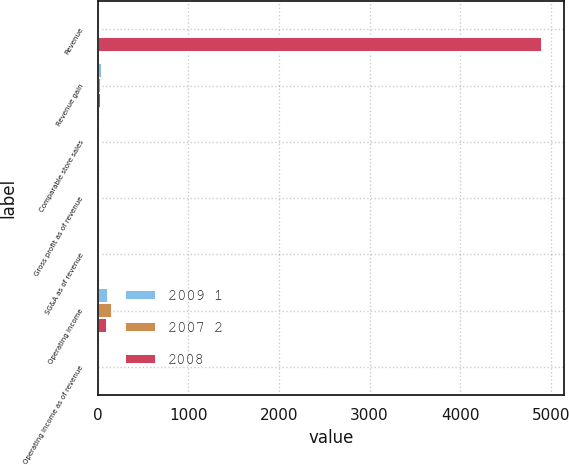<chart> <loc_0><loc_0><loc_500><loc_500><stacked_bar_chart><ecel><fcel>Revenue<fcel>Revenue gain<fcel>Comparable store sales<fcel>Gross profit as of revenue<fcel>SG&A as of revenue<fcel>Operating income<fcel>Operating income as of revenue<nl><fcel>2009 1<fcel>21.6<fcel>49<fcel>0.9<fcel>23.9<fcel>22.7<fcel>112<fcel>1.1<nl><fcel>2007 2<fcel>21.6<fcel>37<fcel>9<fcel>20.7<fcel>18.3<fcel>162<fcel>2.4<nl><fcel>2008<fcel>4903<fcel>41<fcel>11.7<fcel>21.6<fcel>19.6<fcel>99<fcel>2<nl></chart> 